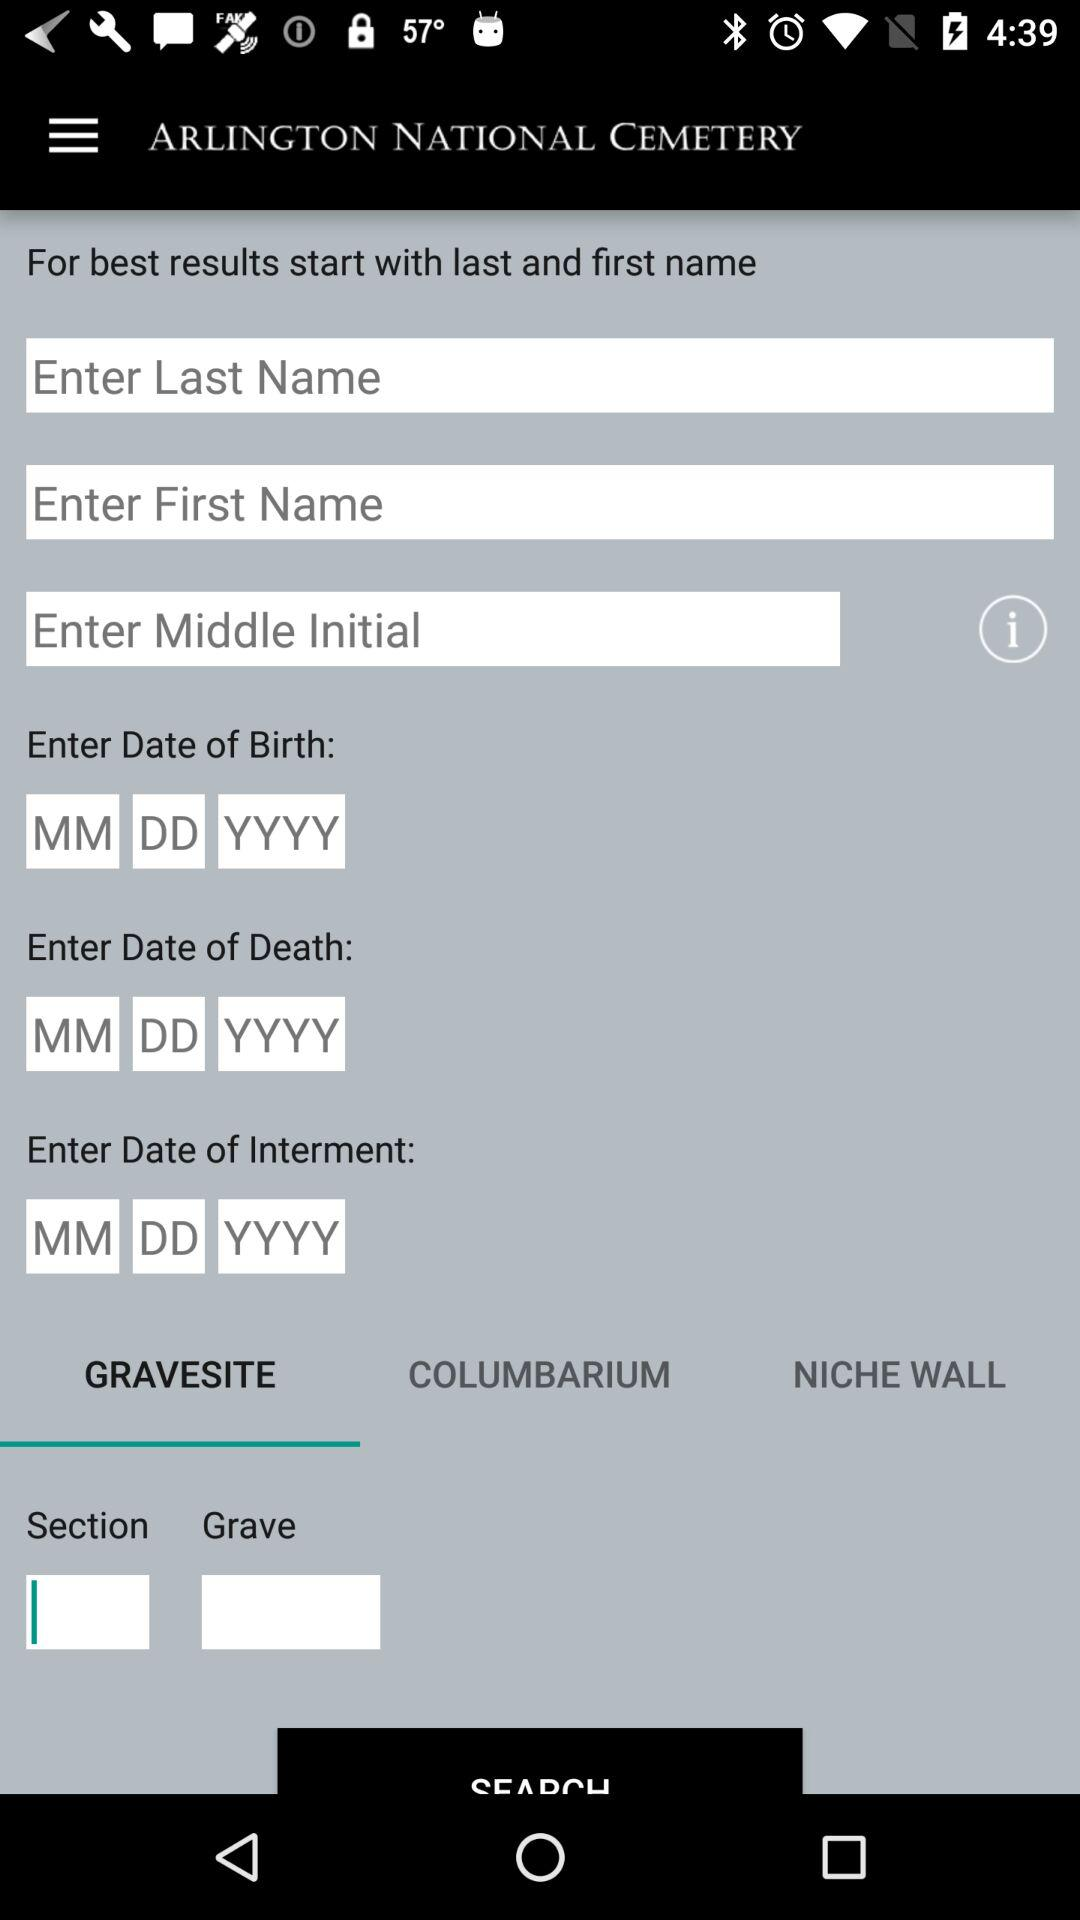Which is the selected tab? The selected tab is "Gravesite". 